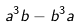Convert formula to latex. <formula><loc_0><loc_0><loc_500><loc_500>a ^ { 3 } b - b ^ { 3 } a</formula> 